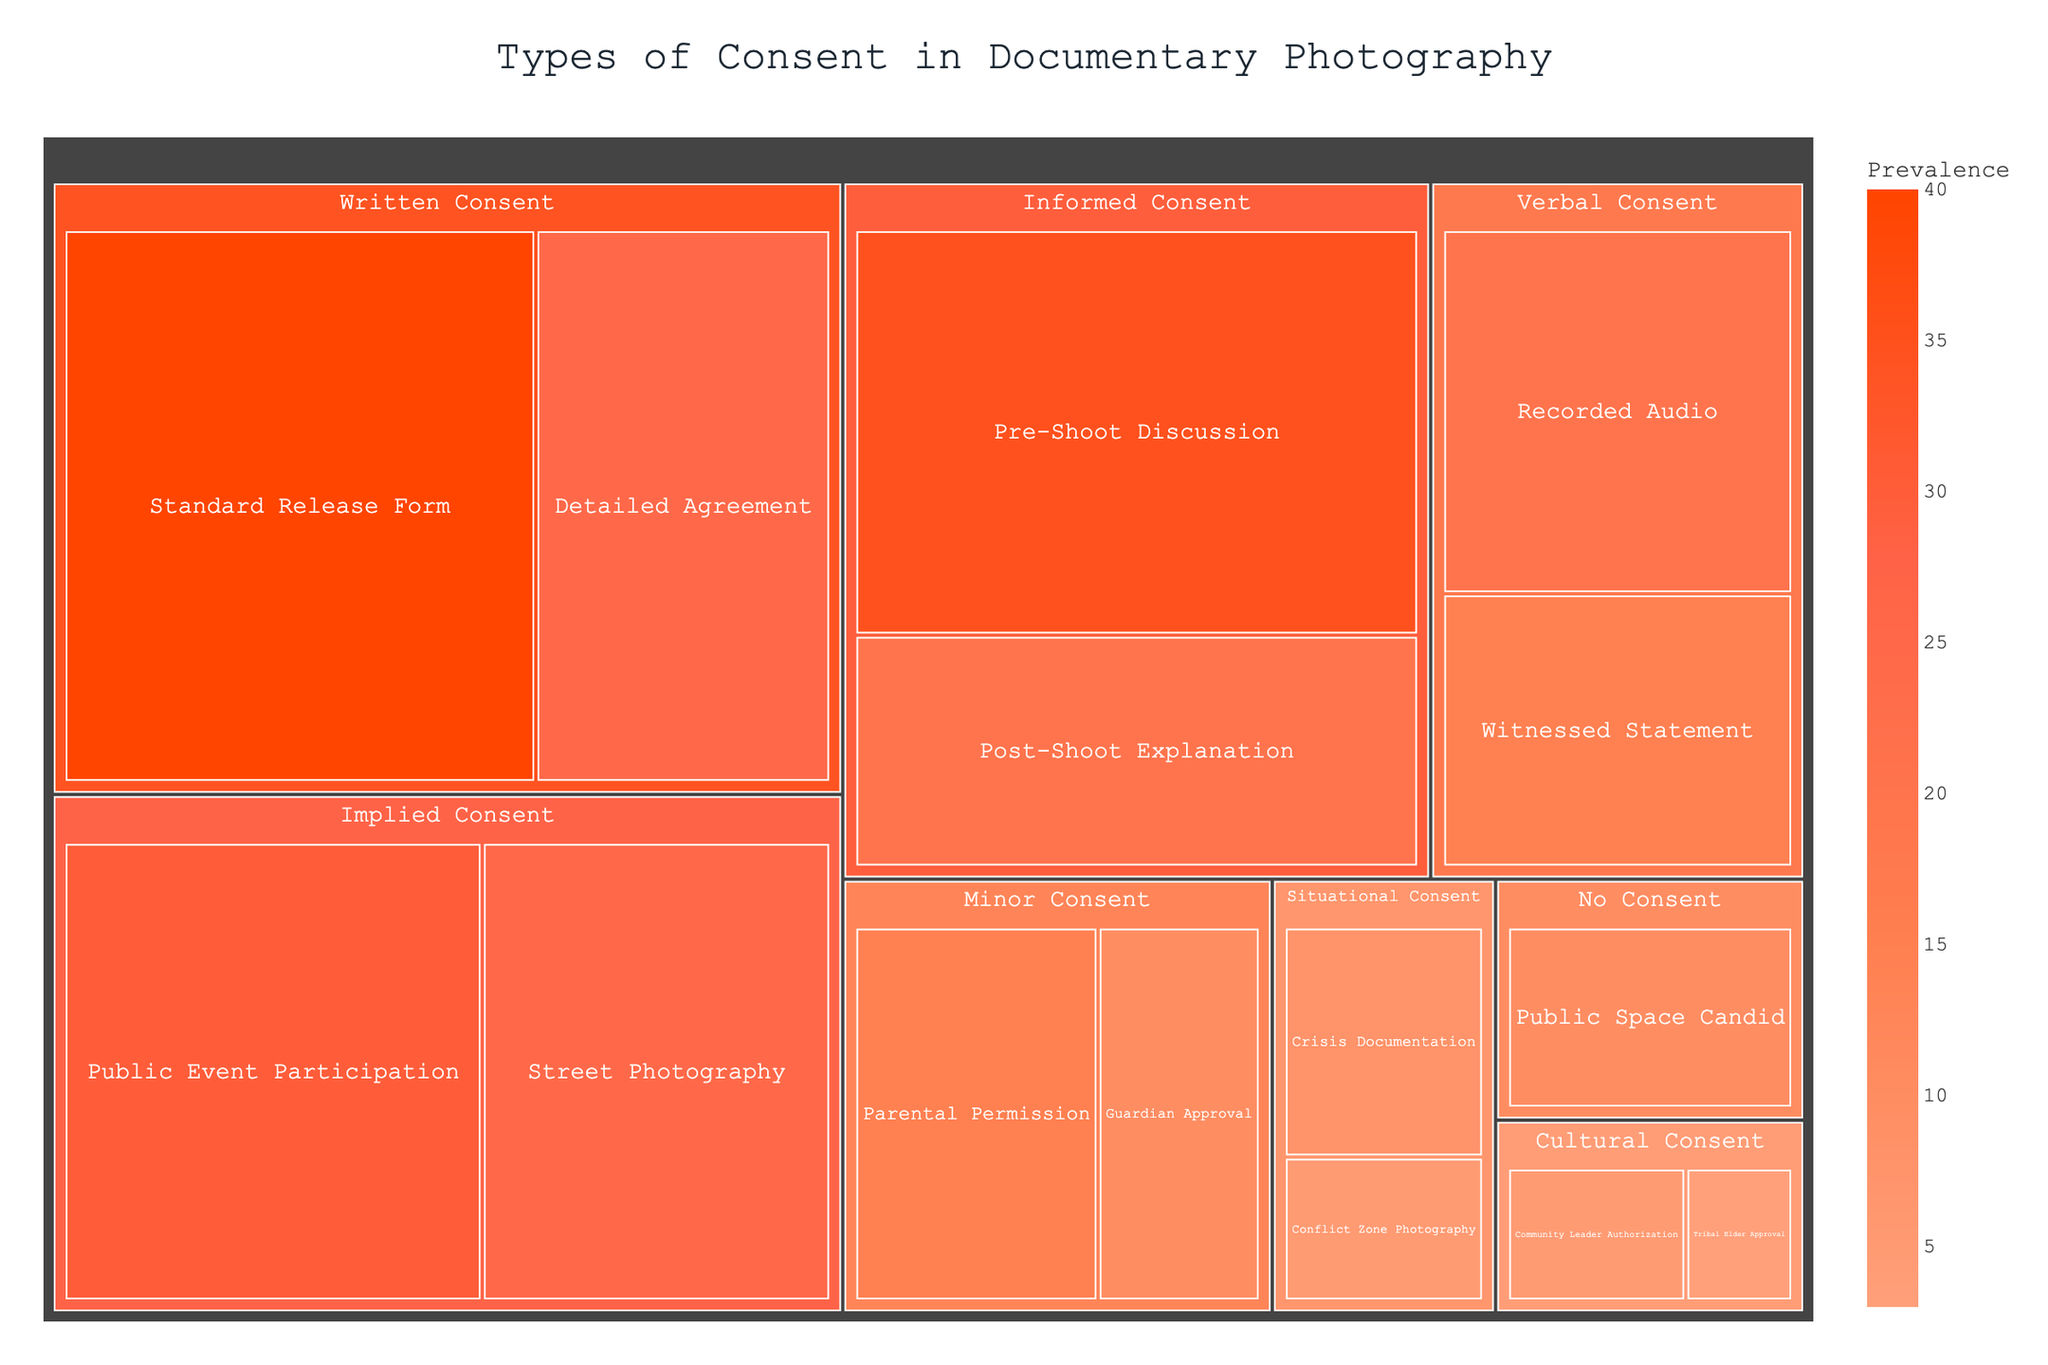What is the title of the treemap? The title is usually found at the top of the treemap and summarizes what the visual represents.
Answer: Types of Consent in Documentary Photography Which type of consent has the highest prevalence? Look for the largest and most prominently colored section in the treemap. The section with the largest area corresponds to the highest prevalence.
Answer: Written Consent (Standard Release Form) How many consent methods are shown for Written Consent? Identify the major sections labeled 'Written Consent', then count the sub-sections representing individual methods.
Answer: 2 What is the combined prevalence of Verbal Consent methods? Add the prevalences of the methods under 'Verbal Consent': Recorded Audio and Witnessed Statement.
Answer: 35 Which consent method under Implied Consent has a higher prevalence? Compare the sizes of the sections under 'Implied Consent'.
Answer: Public Event Participation What is the least prevalent consent method shown in the treemap? Look for the smallest colored section; hover over it if necessary to read the method name.
Answer: Cultural Consent (Tribal Elder Approval) What is the total prevalence of Minor Consent methods? Sum the prevalence values for Parental Permission and Guardian Approval listed under 'Minor Consent'.
Answer: 25 Compare the prevalence of Informed Consent (Pre-Shoot Discussion) to Public Space Candid. Which one is higher? Check the sizes or the prevalence values of the two specified sections.
Answer: Informed Consent (Pre-Shoot Discussion) What is the average prevalence of the methods listed under Situational Consent? Add the prevalences of Crisis Documentation and Conflict Zone Photography, then divide by the number of methods (2).
Answer: 6.5 Which type of consent is not categorized under any form of written or verbal agreement? Identify the consent types that do not involve formal or verbal statements by looking for categories like 'Implied Consent' or 'No Consent'.
Answer: Implied Consent, No Consent 